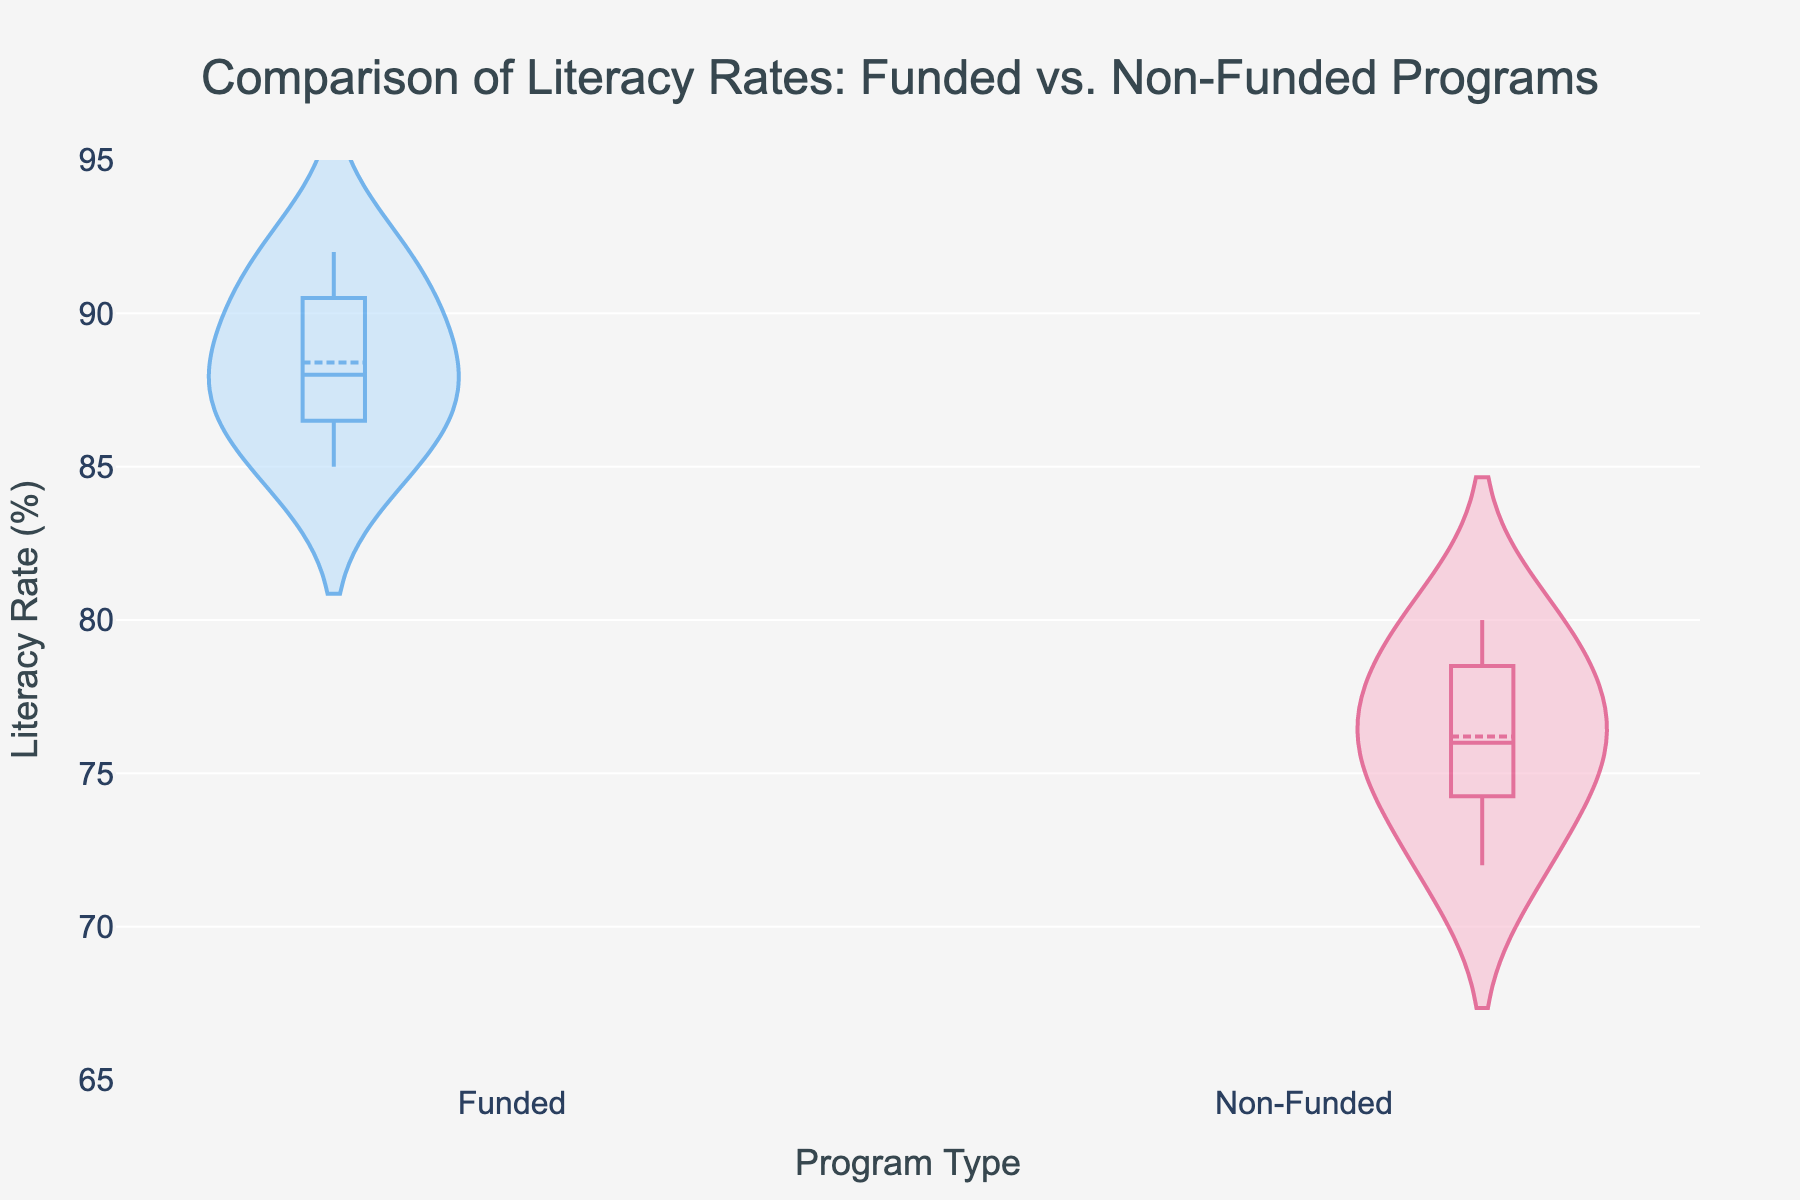What's the title of the figure? The title of the figure is displayed prominently at the top of the plot.
Answer: Comparison of Literacy Rates: Funded vs. Non-Funded Programs Which color represents the funded programs? The funded programs are represented by a specific color in the plot.
Answer: Blue What is the mean literacy rate for funded programs? The mean line is visible on the plot and is specific to each group. Estimate where the mean line sits for the funded programs.
Answer: Around 88% How do the literacy rates of non-funded programs vary? Observe the spread of the data points in the violin plot for the non-funded programs.
Answer: The rates vary from around 72% to 80% Which group has a higher median literacy rate, funded or non-funded? Look at the central value within each violin plot. The median is generally marked visibly.
Answer: Funded Between which values do most of the literacy rates for funded programs fall? The "bulge" of the violin plot indicates where most values are located.
Answer: Between 85% and 92% What is the range of literacy rates for non-funded programs? Identify the minimum and maximum values from the violin plot of non-funded programs.
Answer: 72% to 80% Does the funded group have a greater variation in literacy rates compared to the non-funded group? Compare the spread of the violin plots for both groups to see which one has a greater range of values.
Answer: No, non-funded has a greater variation How does the average literacy rate of non-funded programs compare to funded programs? Compare the mean lines of both groups. Determine if the funded programs have a notably higher mean rate.
Answer: Non-funded is lower Are there any overlapping literacy rates between funded and non-funded programs? Identify areas where the violin plots of both groups might overlap.
Answer: Yes, between 85% and 87% 